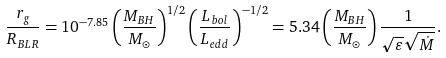Convert formula to latex. <formula><loc_0><loc_0><loc_500><loc_500>\frac { r _ { g } } { R _ { B L R } } = 1 0 ^ { - 7 . 8 5 } \left ( \frac { M _ { B H } } { M _ { \odot } } \right ) ^ { 1 / 2 } \left ( \frac { L _ { b o l } } { L _ { e d d } } \right ) ^ { - 1 / 2 } = 5 . 3 4 \left ( \frac { M _ { B H } } { M _ { \odot } } \right ) \frac { 1 } { \sqrt { \varepsilon } \sqrt { \dot { M } } } .</formula> 